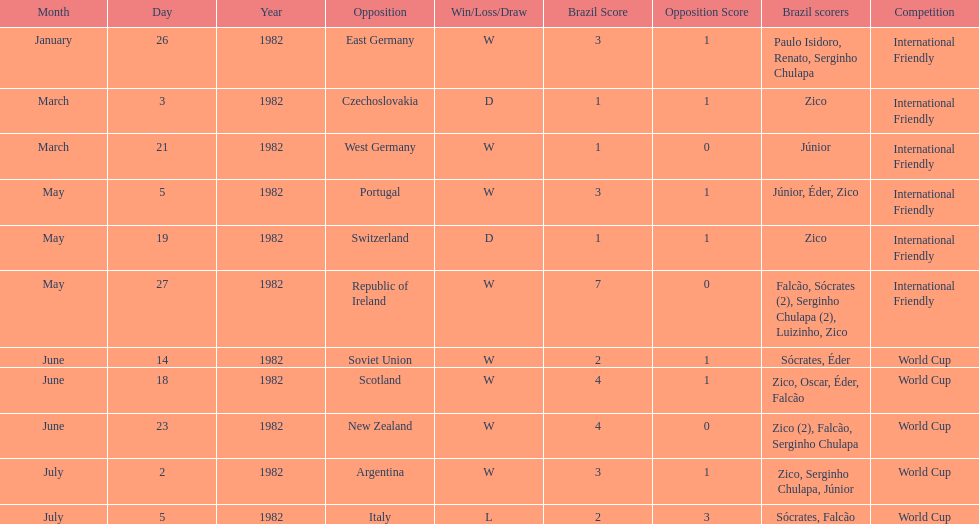How many games did zico end up scoring in during this season? 7. 